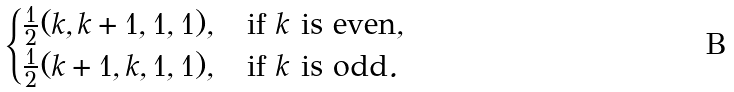<formula> <loc_0><loc_0><loc_500><loc_500>\begin{cases} \frac { 1 } { 2 } ( k , k + 1 , 1 , 1 ) , & \text {if } k \text { is even} , \\ \frac { 1 } { 2 } ( k + 1 , k , 1 , 1 ) , & \text {if } k \text { is odd} . \end{cases}</formula> 